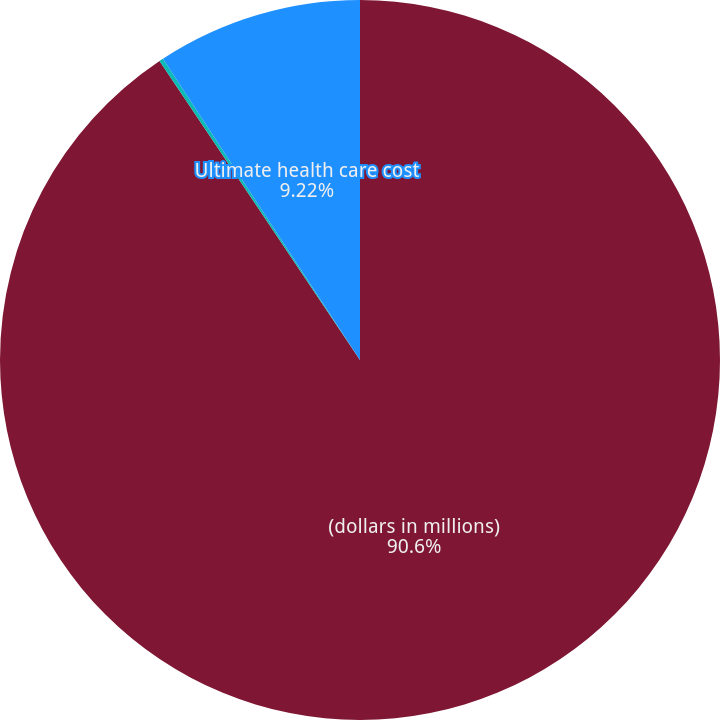<chart> <loc_0><loc_0><loc_500><loc_500><pie_chart><fcel>(dollars in millions)<fcel>Discount rate<fcel>Ultimate health care cost<nl><fcel>90.6%<fcel>0.18%<fcel>9.22%<nl></chart> 